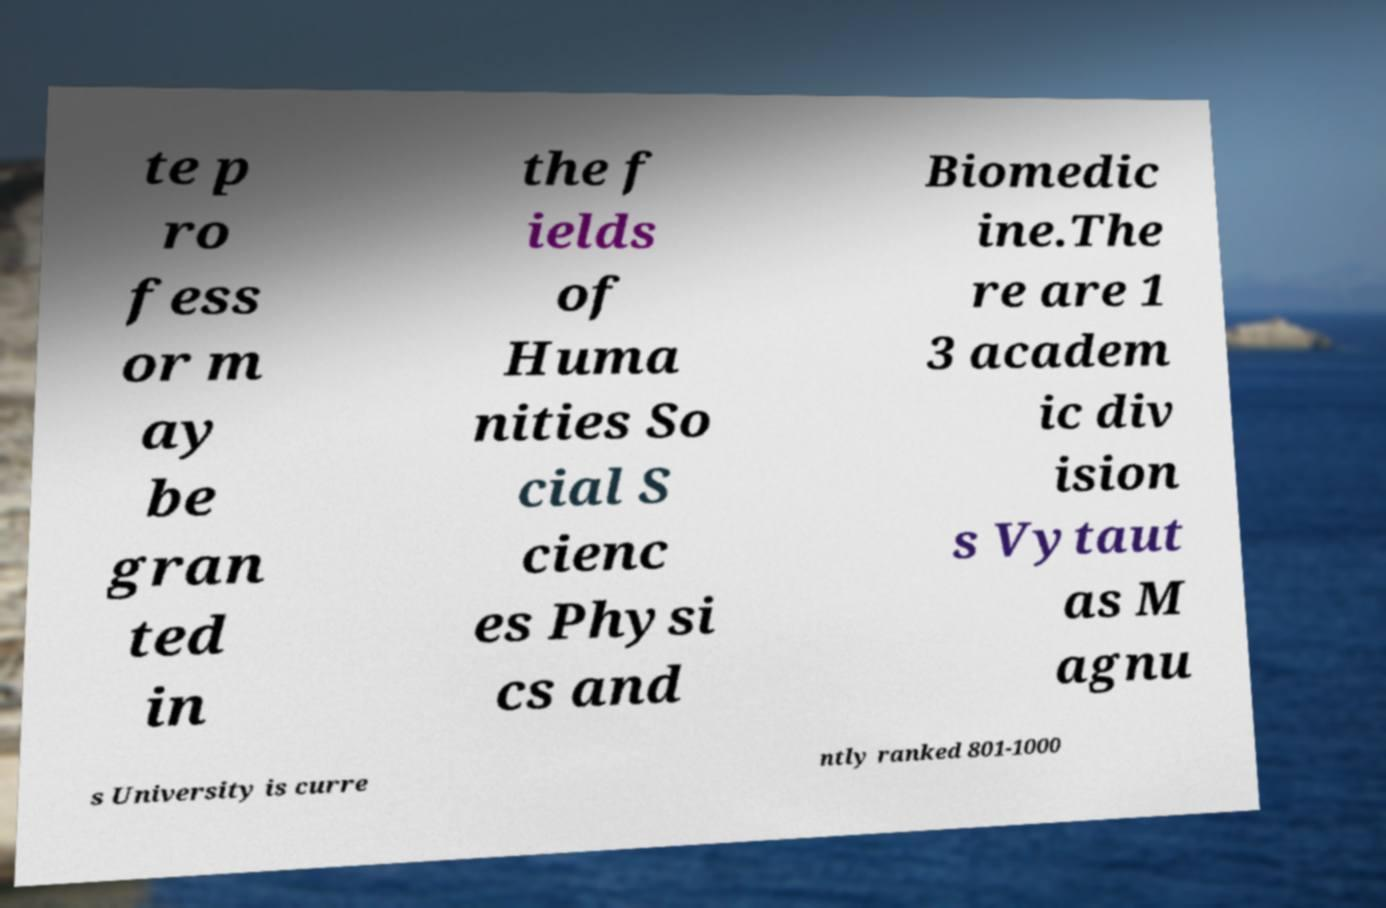Could you extract and type out the text from this image? te p ro fess or m ay be gran ted in the f ields of Huma nities So cial S cienc es Physi cs and Biomedic ine.The re are 1 3 academ ic div ision s Vytaut as M agnu s University is curre ntly ranked 801-1000 